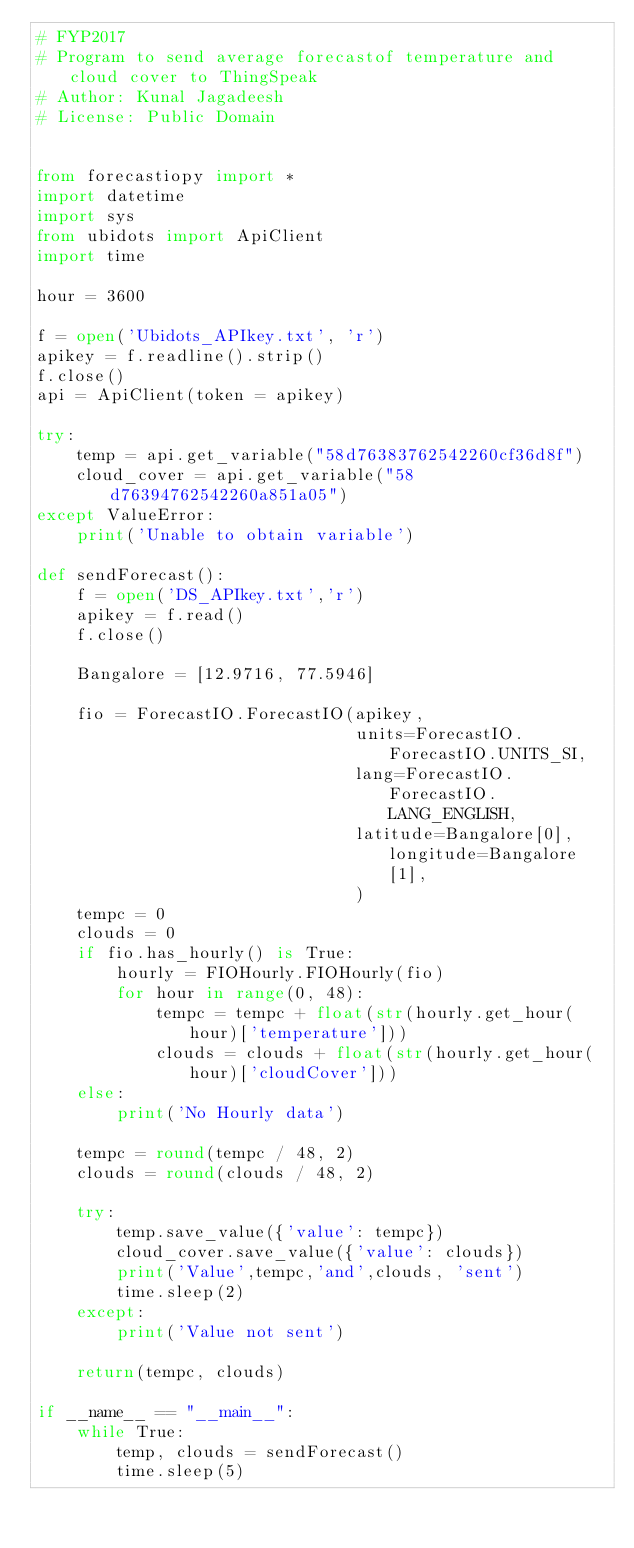Convert code to text. <code><loc_0><loc_0><loc_500><loc_500><_Python_># FYP2017
# Program to send average forecastof temperature and cloud cover to ThingSpeak
# Author: Kunal Jagadeesh
# License: Public Domain


from forecastiopy import *
import datetime
import sys
from ubidots import ApiClient
import time

hour = 3600

f = open('Ubidots_APIkey.txt', 'r')
apikey = f.readline().strip()
f.close()
api = ApiClient(token = apikey)

try:
    temp = api.get_variable("58d76383762542260cf36d8f")
    cloud_cover = api.get_variable("58d76394762542260a851a05")
except ValueError:
    print('Unable to obtain variable')
    
def sendForecast():
    f = open('DS_APIkey.txt','r')
    apikey = f.read()
    f.close()

    Bangalore = [12.9716, 77.5946]

    fio = ForecastIO.ForecastIO(apikey,
                                units=ForecastIO.ForecastIO.UNITS_SI,
                                lang=ForecastIO.ForecastIO.LANG_ENGLISH,
                                latitude=Bangalore[0], longitude=Bangalore[1],
                                )
    tempc = 0
    clouds = 0
    if fio.has_hourly() is True:
        hourly = FIOHourly.FIOHourly(fio)
        for hour in range(0, 48):
            tempc = tempc + float(str(hourly.get_hour(hour)['temperature']))
            clouds = clouds + float(str(hourly.get_hour(hour)['cloudCover']))
    else:
        print('No Hourly data')

    tempc = round(tempc / 48, 2)
    clouds = round(clouds / 48, 2)

    try:
        temp.save_value({'value': tempc})
        cloud_cover.save_value({'value': clouds})
        print('Value',tempc,'and',clouds, 'sent')
        time.sleep(2)
    except:
        print('Value not sent')
	
    return(tempc, clouds)

if __name__ == "__main__":
    while True:
        temp, clouds = sendForecast()
        time.sleep(5)
    
</code> 